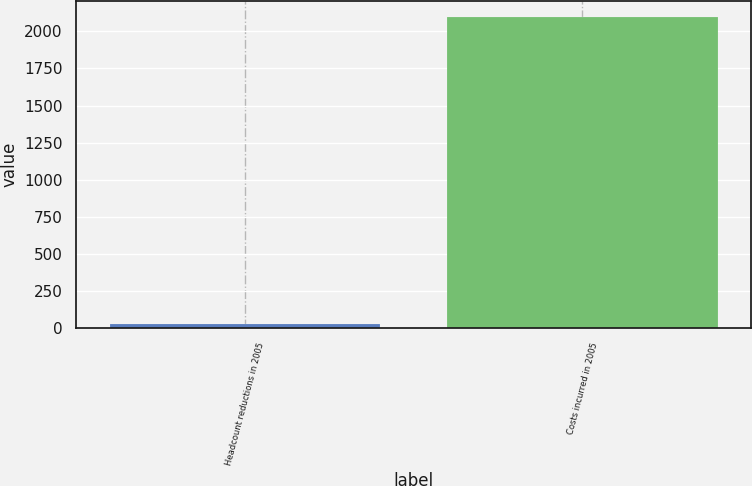Convert chart to OTSL. <chart><loc_0><loc_0><loc_500><loc_500><bar_chart><fcel>Headcount reductions in 2005<fcel>Costs incurred in 2005<nl><fcel>29<fcel>2097<nl></chart> 